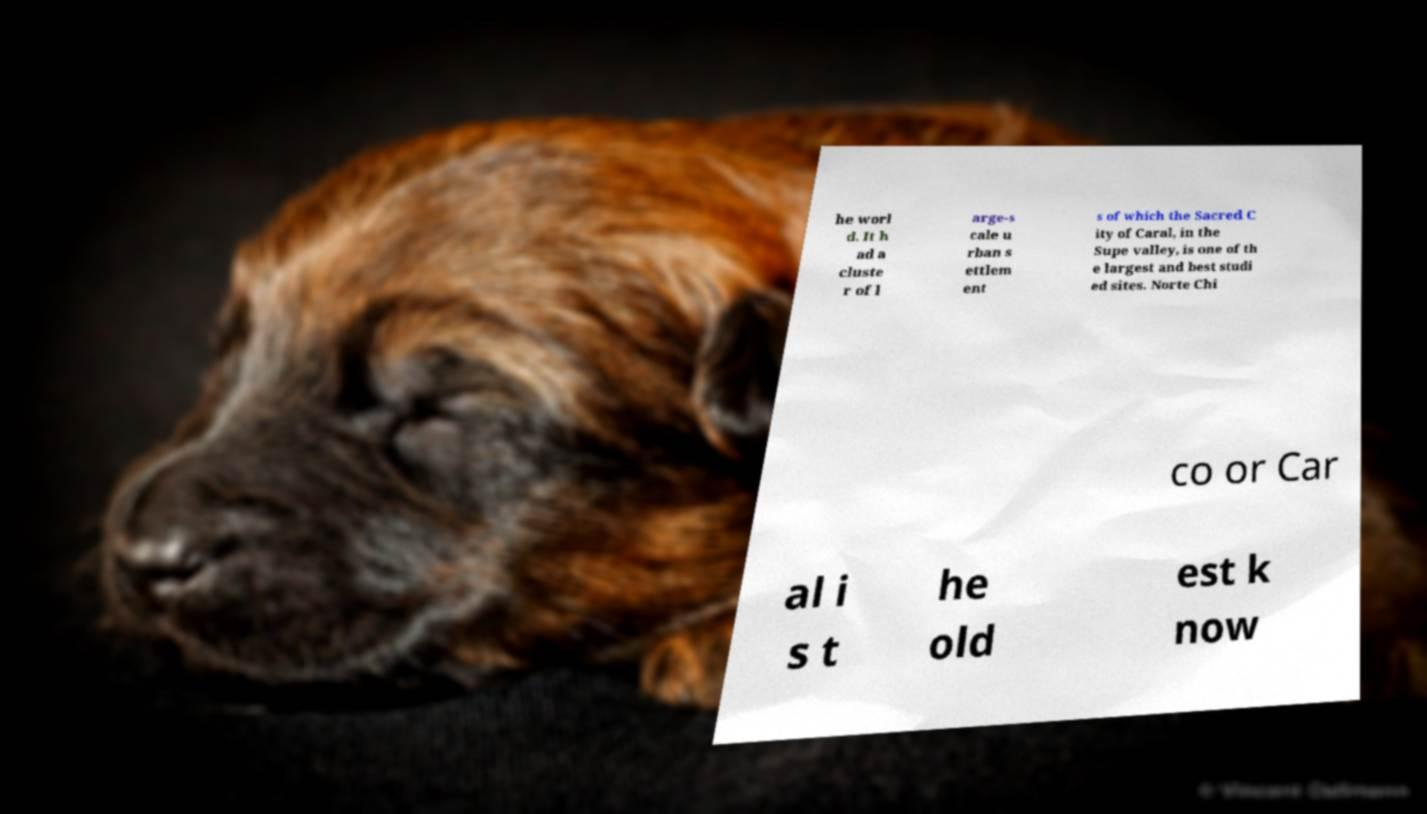There's text embedded in this image that I need extracted. Can you transcribe it verbatim? he worl d. It h ad a cluste r of l arge-s cale u rban s ettlem ent s of which the Sacred C ity of Caral, in the Supe valley, is one of th e largest and best studi ed sites. Norte Chi co or Car al i s t he old est k now 